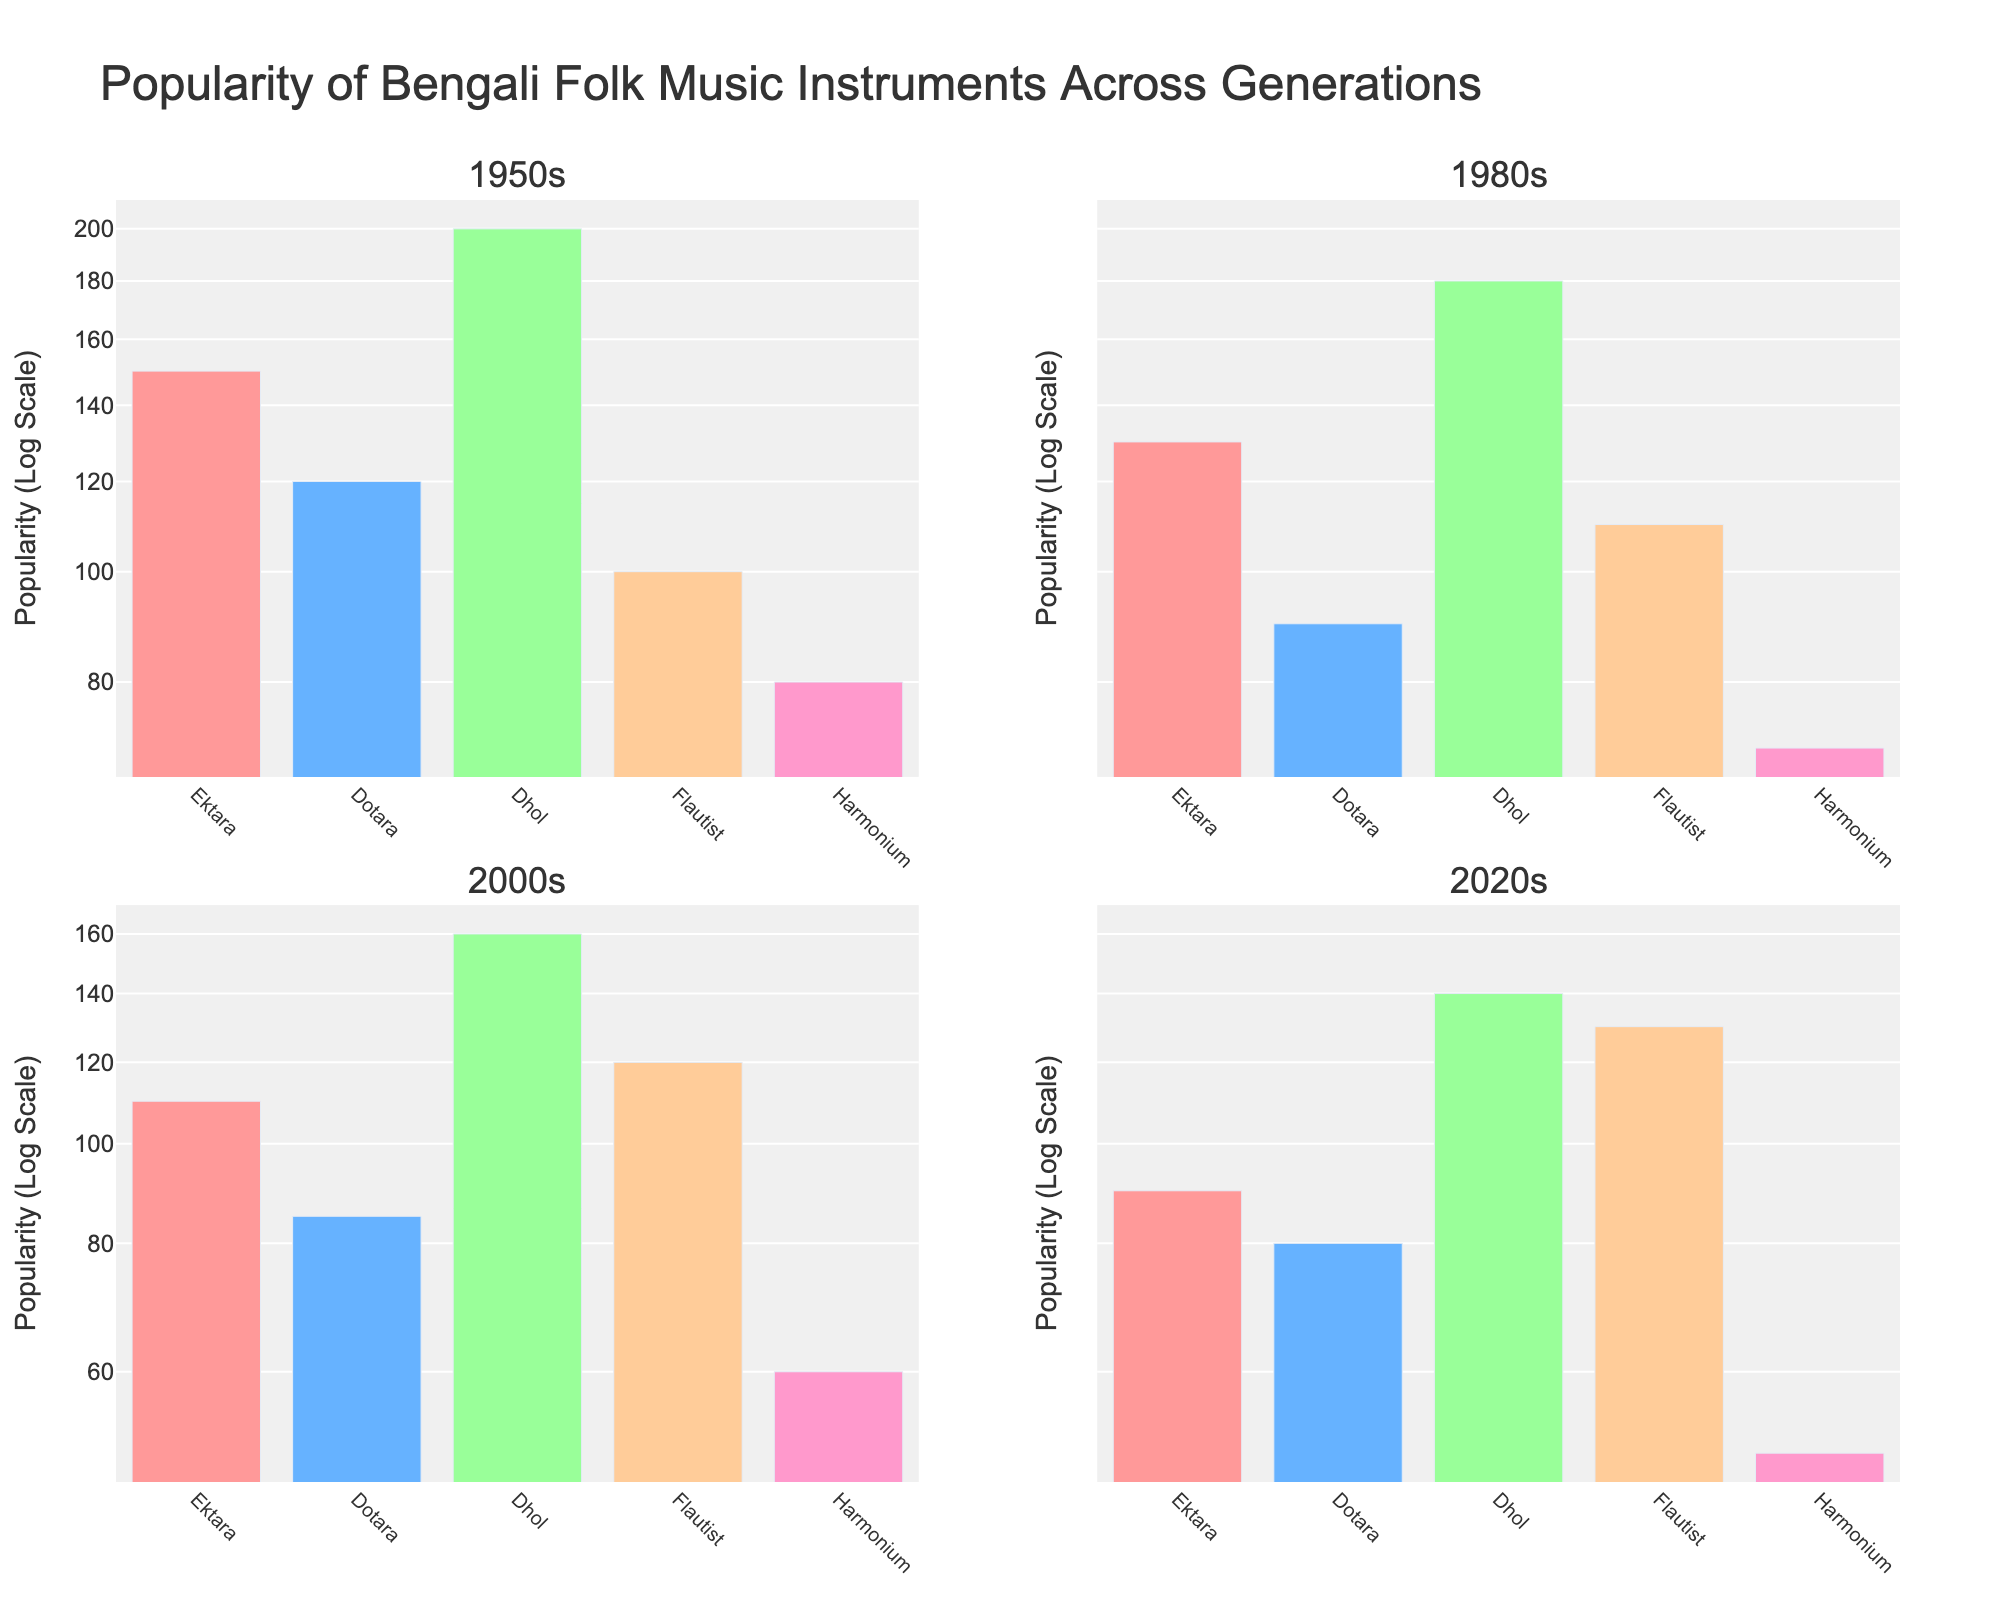what is the title of the subplot figure? The title of a figure is typically displayed at the top of the visual. In this subplot, it is prominently stated.
Answer: Popularity of Bengali Folk Music Instruments Across Generations Which generation has the highest popularity for the Dhol instrument? By comparing the bars for the Dhol instrument across each subplot, you can determine the tallest bar, which corresponds to the highest popularity.
Answer: 1950s How has the popularity of the Harmonium changed from the 1950s to the 2020s? Locate the bars for the Harmonium across subplots from different generations and observe the trend. The popularity of the Harmonium shows a decline over the decades.
Answer: Decreased What can you infer about the popularity of the Ektara instrument from the 1950s to the 2020s? Examine the heights of the Ektara bars across the different subplots to identify the trend. Each bar indicates the relative popularity on a logarithmic scale.
Answer: Decreased Which instrument saw an increase in popularity from the 1950s to the 2020s while others decreased? Analyze the heights of the bars for each instrument across all generations to see which one increased. The Flautist is the only instrument that increased in popularity.
Answer: Flautist What is the logarithmic scale used for the y-axis? Observe the labeling of the y-axis, which should indicate the scale type as well as the unit of measurement. This is used to display a wide range of values compactly.
Answer: Logarithmic scale Which generation shows the least popularity for the Dotara instrument? By observing the heights of the Dotara bars across all subplots, identify which generation has the smallest bar.
Answer: 2020s Compare the popularity between the Flautist and Harmonium in the 1980s. Which one was more popular? Observing the heights of the bars for the Flautist and Harmonium in the 1980s subplot shows which bar is taller and hence more popular.
Answer: Flautist What is the dominant instrument in the 2020s generation in terms of popularity? The instrument with the tallest bar in the 2020s subplot indicates the dominant one in terms of popularity.
Answer: Dhol How much has the popularity of the Dhol instrument reduced from the 1950s to the 2020s? Observe and compare the heights of the Dhol bars in the 1950s and 2020s subplots.
Answer: 60 